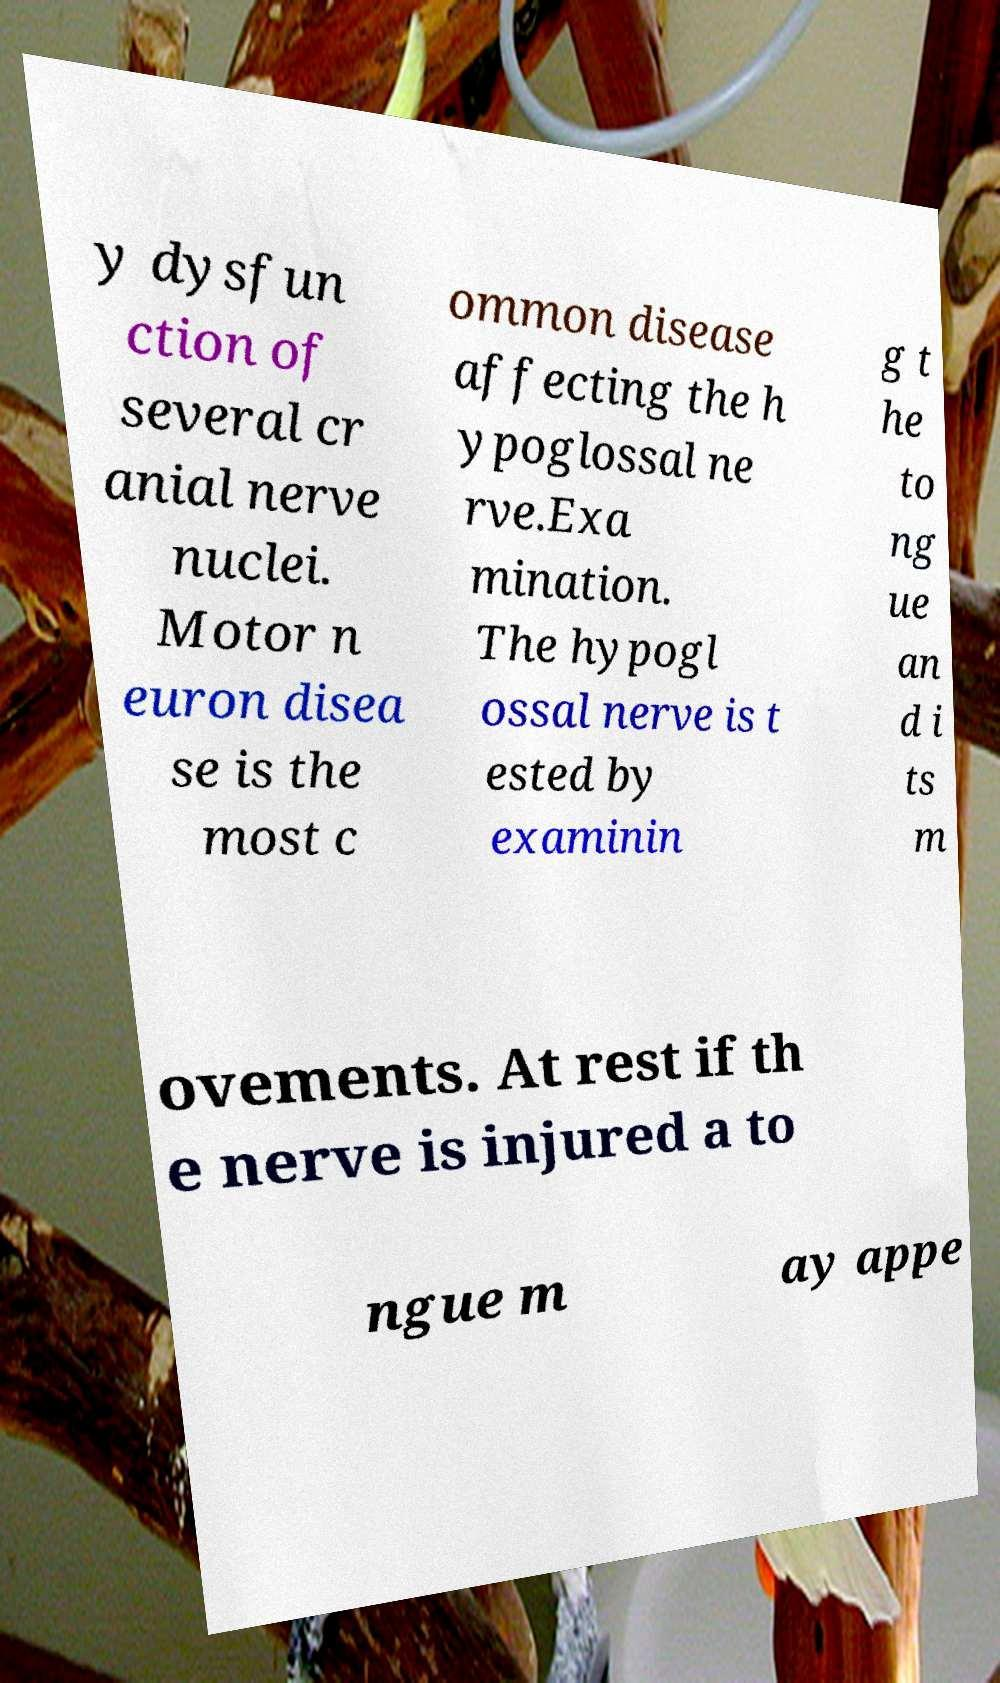Please identify and transcribe the text found in this image. y dysfun ction of several cr anial nerve nuclei. Motor n euron disea se is the most c ommon disease affecting the h ypoglossal ne rve.Exa mination. The hypogl ossal nerve is t ested by examinin g t he to ng ue an d i ts m ovements. At rest if th e nerve is injured a to ngue m ay appe 